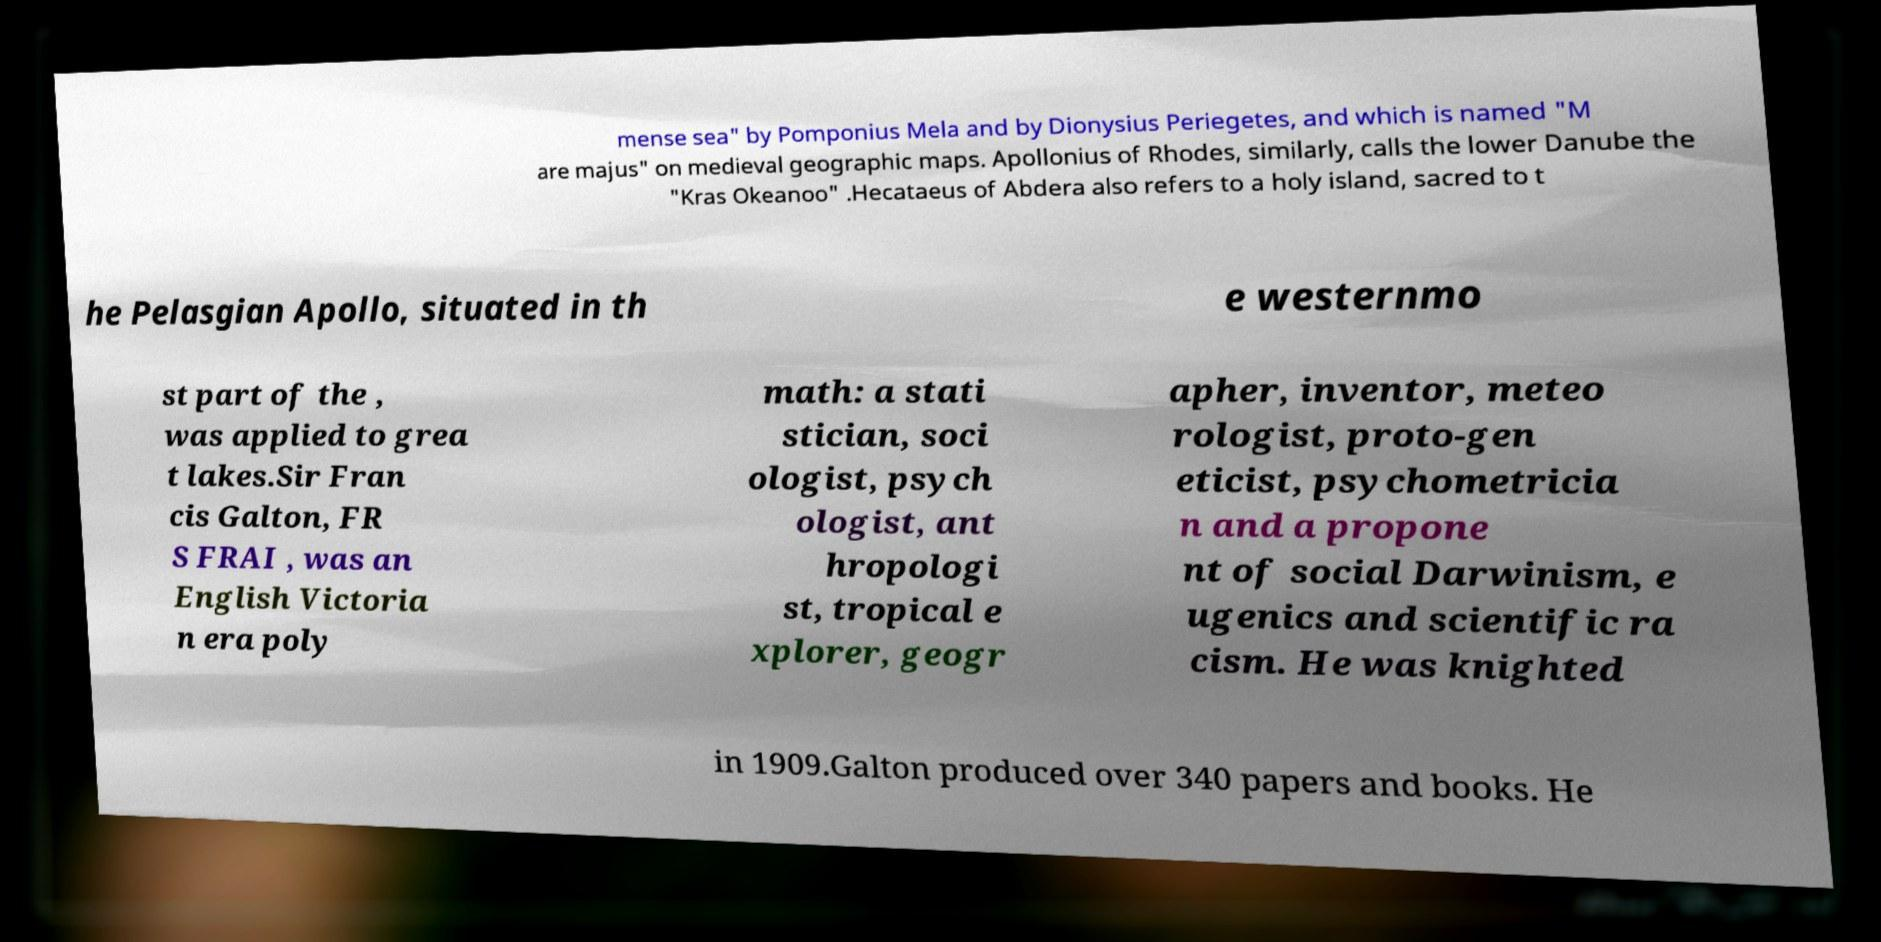What messages or text are displayed in this image? I need them in a readable, typed format. mense sea" by Pomponius Mela and by Dionysius Periegetes, and which is named "M are majus" on medieval geographic maps. Apollonius of Rhodes, similarly, calls the lower Danube the "Kras Okeanoo" .Hecataeus of Abdera also refers to a holy island, sacred to t he Pelasgian Apollo, situated in th e westernmo st part of the , was applied to grea t lakes.Sir Fran cis Galton, FR S FRAI , was an English Victoria n era poly math: a stati stician, soci ologist, psych ologist, ant hropologi st, tropical e xplorer, geogr apher, inventor, meteo rologist, proto-gen eticist, psychometricia n and a propone nt of social Darwinism, e ugenics and scientific ra cism. He was knighted in 1909.Galton produced over 340 papers and books. He 